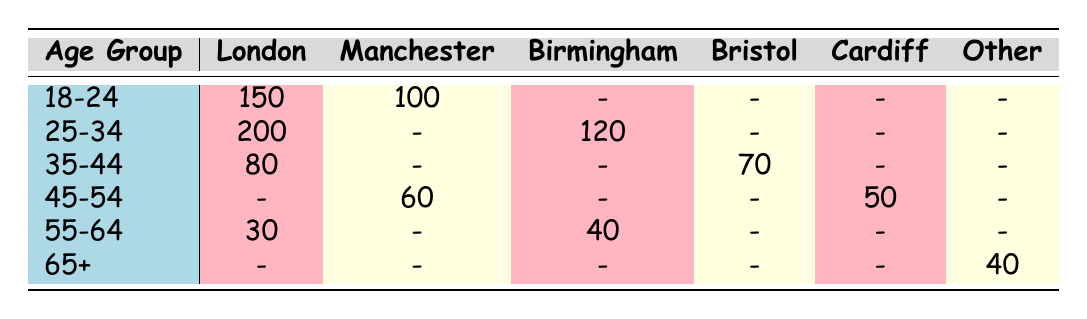How many clients aged 18-24 are located in London? Referring to the table, the ClientCount for the AgeGroup "18-24" in "London" is directly listed as 150.
Answer: 150 Which city has the highest number of clients in the age group 25-34? The data for the "25-34" age group shows that London has 200 clients, which is more than Birmingham at 120. Hence, London is the city with the highest number.
Answer: London What is the total count of clients aged 45-54 across all locations listed? The counts for the age group "45-54" are 60 from Manchester and 50 from Cardiff, summing these gives 60 + 50 = 110.
Answer: 110 Is there any client aged 65 or older in Birmingham? According to the table, there are no clients aged 65+ listed for Birmingham, hence the answer is no.
Answer: No In which location do we find clients aged 55-64 and what is their total count? The locations for age group "55-64" are Birmingham with 40 clients and London with 30 clients. Adding these gives 40 + 30 = 70 clients in total, located in these two cities.
Answer: 70 Are there any clients aged 35-44 in Manchester? The table shows that there are no clients aged 35-44 in Manchester, confirming the answer is no.
Answer: No What is the difference in client count between the "25-34" age group in London and "45-54" age group in Manchester? In London, the client count for the "25-34" group is 200, while in Manchester for "45-54" it is 60. The difference is 200 - 60 = 140.
Answer: 140 Which age group has the lowest number of clients in Cardiff? The table indicates that Cardiff has clients in the "45-54" age group (50) but none in the other groups listed, thus making "45-54" the lowest age group present in Cardiff.
Answer: 45-54 How many clients do we have in total for the age group 65+? The data shows there are 25 clients in Edinburgh and 15 in Liverpool for the age group "65+". Adding these yields a total of 25 + 15 = 40 clients aged 65+.
Answer: 40 